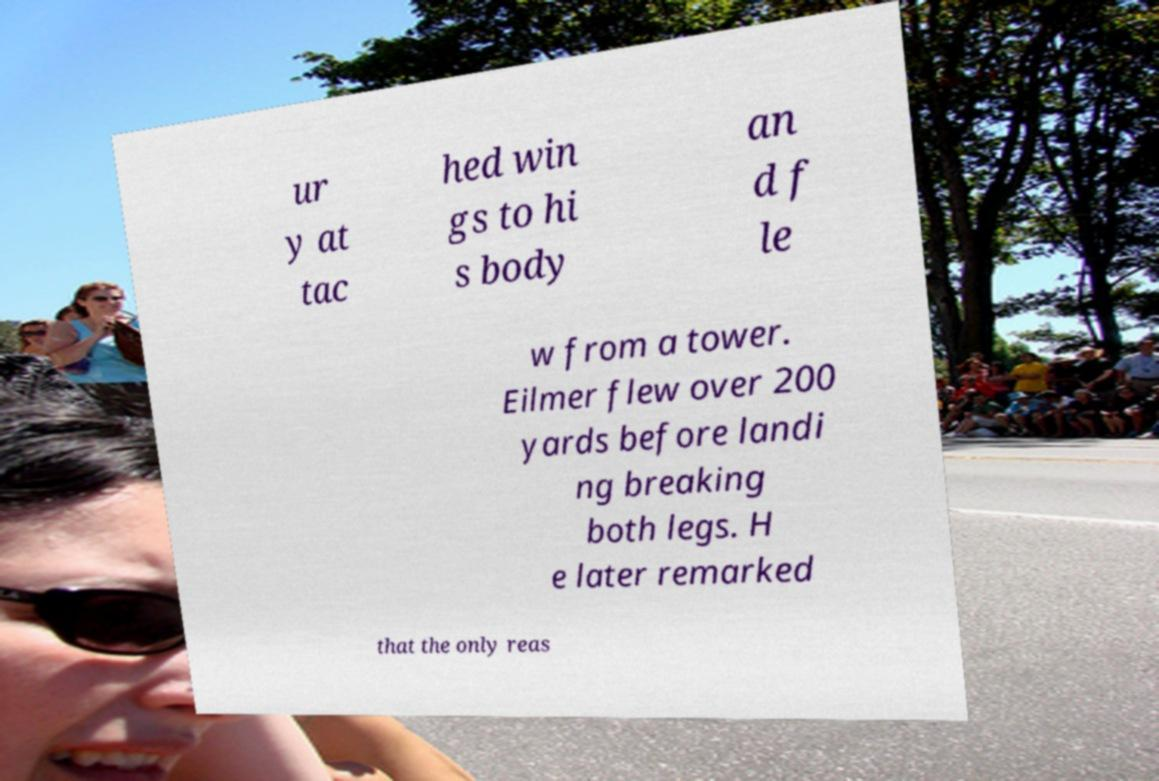There's text embedded in this image that I need extracted. Can you transcribe it verbatim? ur y at tac hed win gs to hi s body an d f le w from a tower. Eilmer flew over 200 yards before landi ng breaking both legs. H e later remarked that the only reas 